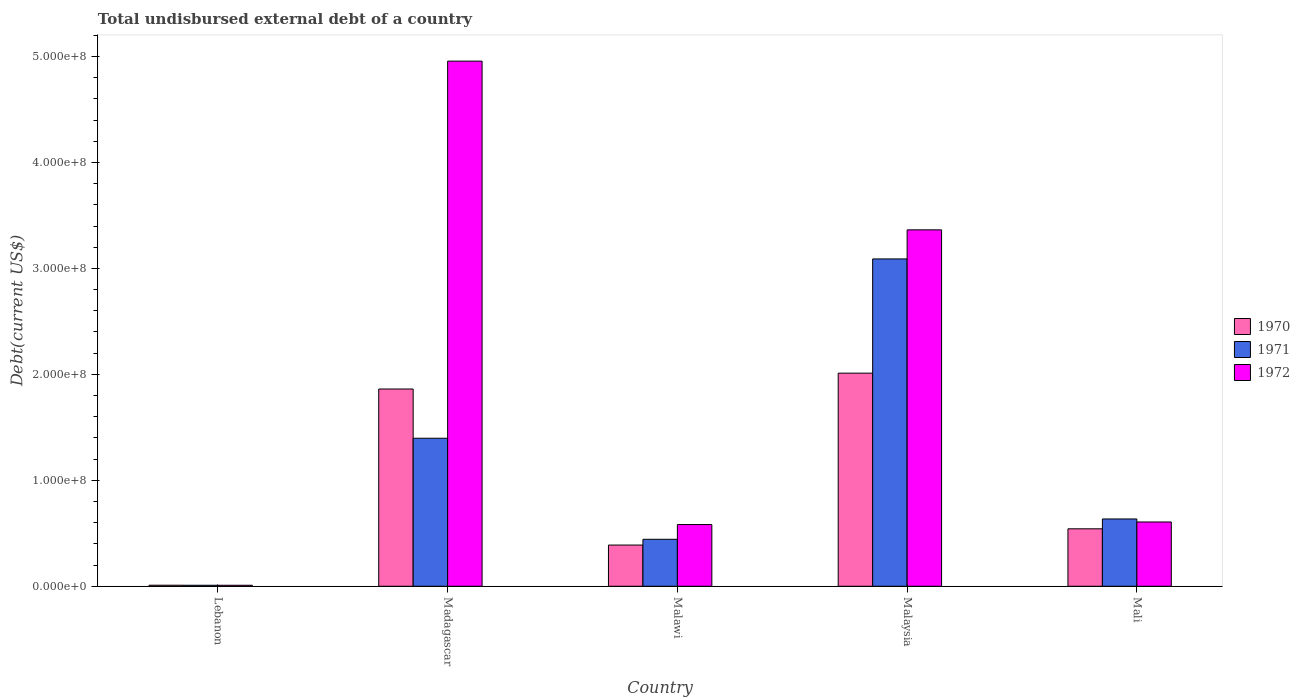Are the number of bars per tick equal to the number of legend labels?
Your answer should be compact. Yes. Are the number of bars on each tick of the X-axis equal?
Offer a terse response. Yes. What is the label of the 3rd group of bars from the left?
Give a very brief answer. Malawi. What is the total undisbursed external debt in 1971 in Lebanon?
Offer a terse response. 9.32e+05. Across all countries, what is the maximum total undisbursed external debt in 1971?
Your answer should be compact. 3.09e+08. Across all countries, what is the minimum total undisbursed external debt in 1971?
Your answer should be compact. 9.32e+05. In which country was the total undisbursed external debt in 1971 maximum?
Give a very brief answer. Malaysia. In which country was the total undisbursed external debt in 1970 minimum?
Keep it short and to the point. Lebanon. What is the total total undisbursed external debt in 1972 in the graph?
Provide a short and direct response. 9.52e+08. What is the difference between the total undisbursed external debt in 1971 in Lebanon and that in Mali?
Your response must be concise. -6.26e+07. What is the difference between the total undisbursed external debt in 1971 in Malawi and the total undisbursed external debt in 1970 in Malaysia?
Offer a terse response. -1.57e+08. What is the average total undisbursed external debt in 1970 per country?
Keep it short and to the point. 9.63e+07. What is the difference between the total undisbursed external debt of/in 1970 and total undisbursed external debt of/in 1971 in Malaysia?
Your answer should be very brief. -1.08e+08. In how many countries, is the total undisbursed external debt in 1970 greater than 480000000 US$?
Ensure brevity in your answer.  0. What is the ratio of the total undisbursed external debt in 1971 in Lebanon to that in Mali?
Your response must be concise. 0.01. Is the total undisbursed external debt in 1972 in Malaysia less than that in Mali?
Offer a terse response. No. Is the difference between the total undisbursed external debt in 1970 in Malawi and Mali greater than the difference between the total undisbursed external debt in 1971 in Malawi and Mali?
Your answer should be very brief. Yes. What is the difference between the highest and the second highest total undisbursed external debt in 1970?
Ensure brevity in your answer.  1.50e+07. What is the difference between the highest and the lowest total undisbursed external debt in 1970?
Your answer should be compact. 2.00e+08. Is the sum of the total undisbursed external debt in 1970 in Malawi and Malaysia greater than the maximum total undisbursed external debt in 1972 across all countries?
Your response must be concise. No. What does the 1st bar from the left in Malaysia represents?
Provide a short and direct response. 1970. What does the 2nd bar from the right in Malawi represents?
Keep it short and to the point. 1971. How many bars are there?
Provide a succinct answer. 15. How many countries are there in the graph?
Give a very brief answer. 5. What is the difference between two consecutive major ticks on the Y-axis?
Your answer should be very brief. 1.00e+08. Does the graph contain any zero values?
Provide a succinct answer. No. What is the title of the graph?
Your answer should be compact. Total undisbursed external debt of a country. What is the label or title of the Y-axis?
Offer a terse response. Debt(current US$). What is the Debt(current US$) in 1970 in Lebanon?
Your answer should be very brief. 9.80e+05. What is the Debt(current US$) of 1971 in Lebanon?
Provide a short and direct response. 9.32e+05. What is the Debt(current US$) in 1972 in Lebanon?
Your answer should be very brief. 9.32e+05. What is the Debt(current US$) of 1970 in Madagascar?
Provide a short and direct response. 1.86e+08. What is the Debt(current US$) in 1971 in Madagascar?
Provide a succinct answer. 1.40e+08. What is the Debt(current US$) in 1972 in Madagascar?
Give a very brief answer. 4.96e+08. What is the Debt(current US$) of 1970 in Malawi?
Ensure brevity in your answer.  3.89e+07. What is the Debt(current US$) of 1971 in Malawi?
Your response must be concise. 4.43e+07. What is the Debt(current US$) of 1972 in Malawi?
Give a very brief answer. 5.83e+07. What is the Debt(current US$) in 1970 in Malaysia?
Your answer should be compact. 2.01e+08. What is the Debt(current US$) of 1971 in Malaysia?
Your response must be concise. 3.09e+08. What is the Debt(current US$) in 1972 in Malaysia?
Make the answer very short. 3.36e+08. What is the Debt(current US$) in 1970 in Mali?
Ensure brevity in your answer.  5.42e+07. What is the Debt(current US$) of 1971 in Mali?
Give a very brief answer. 6.35e+07. What is the Debt(current US$) in 1972 in Mali?
Your response must be concise. 6.07e+07. Across all countries, what is the maximum Debt(current US$) of 1970?
Offer a very short reply. 2.01e+08. Across all countries, what is the maximum Debt(current US$) in 1971?
Offer a very short reply. 3.09e+08. Across all countries, what is the maximum Debt(current US$) in 1972?
Offer a very short reply. 4.96e+08. Across all countries, what is the minimum Debt(current US$) in 1970?
Your response must be concise. 9.80e+05. Across all countries, what is the minimum Debt(current US$) in 1971?
Keep it short and to the point. 9.32e+05. Across all countries, what is the minimum Debt(current US$) of 1972?
Give a very brief answer. 9.32e+05. What is the total Debt(current US$) in 1970 in the graph?
Give a very brief answer. 4.81e+08. What is the total Debt(current US$) of 1971 in the graph?
Keep it short and to the point. 5.57e+08. What is the total Debt(current US$) in 1972 in the graph?
Offer a very short reply. 9.52e+08. What is the difference between the Debt(current US$) in 1970 in Lebanon and that in Madagascar?
Your response must be concise. -1.85e+08. What is the difference between the Debt(current US$) in 1971 in Lebanon and that in Madagascar?
Provide a short and direct response. -1.39e+08. What is the difference between the Debt(current US$) of 1972 in Lebanon and that in Madagascar?
Ensure brevity in your answer.  -4.95e+08. What is the difference between the Debt(current US$) of 1970 in Lebanon and that in Malawi?
Make the answer very short. -3.79e+07. What is the difference between the Debt(current US$) of 1971 in Lebanon and that in Malawi?
Offer a very short reply. -4.34e+07. What is the difference between the Debt(current US$) in 1972 in Lebanon and that in Malawi?
Provide a short and direct response. -5.73e+07. What is the difference between the Debt(current US$) of 1970 in Lebanon and that in Malaysia?
Provide a succinct answer. -2.00e+08. What is the difference between the Debt(current US$) of 1971 in Lebanon and that in Malaysia?
Ensure brevity in your answer.  -3.08e+08. What is the difference between the Debt(current US$) of 1972 in Lebanon and that in Malaysia?
Offer a very short reply. -3.35e+08. What is the difference between the Debt(current US$) of 1970 in Lebanon and that in Mali?
Keep it short and to the point. -5.32e+07. What is the difference between the Debt(current US$) of 1971 in Lebanon and that in Mali?
Make the answer very short. -6.26e+07. What is the difference between the Debt(current US$) in 1972 in Lebanon and that in Mali?
Ensure brevity in your answer.  -5.97e+07. What is the difference between the Debt(current US$) of 1970 in Madagascar and that in Malawi?
Give a very brief answer. 1.47e+08. What is the difference between the Debt(current US$) in 1971 in Madagascar and that in Malawi?
Your answer should be compact. 9.54e+07. What is the difference between the Debt(current US$) of 1972 in Madagascar and that in Malawi?
Give a very brief answer. 4.37e+08. What is the difference between the Debt(current US$) in 1970 in Madagascar and that in Malaysia?
Ensure brevity in your answer.  -1.50e+07. What is the difference between the Debt(current US$) of 1971 in Madagascar and that in Malaysia?
Provide a succinct answer. -1.69e+08. What is the difference between the Debt(current US$) of 1972 in Madagascar and that in Malaysia?
Offer a very short reply. 1.59e+08. What is the difference between the Debt(current US$) in 1970 in Madagascar and that in Mali?
Your response must be concise. 1.32e+08. What is the difference between the Debt(current US$) in 1971 in Madagascar and that in Mali?
Your response must be concise. 7.62e+07. What is the difference between the Debt(current US$) in 1972 in Madagascar and that in Mali?
Your answer should be compact. 4.35e+08. What is the difference between the Debt(current US$) in 1970 in Malawi and that in Malaysia?
Your answer should be very brief. -1.62e+08. What is the difference between the Debt(current US$) of 1971 in Malawi and that in Malaysia?
Your answer should be very brief. -2.65e+08. What is the difference between the Debt(current US$) of 1972 in Malawi and that in Malaysia?
Ensure brevity in your answer.  -2.78e+08. What is the difference between the Debt(current US$) of 1970 in Malawi and that in Mali?
Provide a short and direct response. -1.53e+07. What is the difference between the Debt(current US$) in 1971 in Malawi and that in Mali?
Provide a short and direct response. -1.92e+07. What is the difference between the Debt(current US$) of 1972 in Malawi and that in Mali?
Keep it short and to the point. -2.41e+06. What is the difference between the Debt(current US$) in 1970 in Malaysia and that in Mali?
Give a very brief answer. 1.47e+08. What is the difference between the Debt(current US$) in 1971 in Malaysia and that in Mali?
Provide a succinct answer. 2.45e+08. What is the difference between the Debt(current US$) of 1972 in Malaysia and that in Mali?
Offer a very short reply. 2.76e+08. What is the difference between the Debt(current US$) in 1970 in Lebanon and the Debt(current US$) in 1971 in Madagascar?
Provide a short and direct response. -1.39e+08. What is the difference between the Debt(current US$) in 1970 in Lebanon and the Debt(current US$) in 1972 in Madagascar?
Make the answer very short. -4.95e+08. What is the difference between the Debt(current US$) of 1971 in Lebanon and the Debt(current US$) of 1972 in Madagascar?
Offer a very short reply. -4.95e+08. What is the difference between the Debt(current US$) of 1970 in Lebanon and the Debt(current US$) of 1971 in Malawi?
Provide a succinct answer. -4.34e+07. What is the difference between the Debt(current US$) of 1970 in Lebanon and the Debt(current US$) of 1972 in Malawi?
Ensure brevity in your answer.  -5.73e+07. What is the difference between the Debt(current US$) of 1971 in Lebanon and the Debt(current US$) of 1972 in Malawi?
Give a very brief answer. -5.73e+07. What is the difference between the Debt(current US$) of 1970 in Lebanon and the Debt(current US$) of 1971 in Malaysia?
Offer a terse response. -3.08e+08. What is the difference between the Debt(current US$) in 1970 in Lebanon and the Debt(current US$) in 1972 in Malaysia?
Offer a very short reply. -3.35e+08. What is the difference between the Debt(current US$) of 1971 in Lebanon and the Debt(current US$) of 1972 in Malaysia?
Your answer should be compact. -3.35e+08. What is the difference between the Debt(current US$) of 1970 in Lebanon and the Debt(current US$) of 1971 in Mali?
Your answer should be very brief. -6.25e+07. What is the difference between the Debt(current US$) of 1970 in Lebanon and the Debt(current US$) of 1972 in Mali?
Offer a very short reply. -5.97e+07. What is the difference between the Debt(current US$) of 1971 in Lebanon and the Debt(current US$) of 1972 in Mali?
Give a very brief answer. -5.97e+07. What is the difference between the Debt(current US$) in 1970 in Madagascar and the Debt(current US$) in 1971 in Malawi?
Keep it short and to the point. 1.42e+08. What is the difference between the Debt(current US$) of 1970 in Madagascar and the Debt(current US$) of 1972 in Malawi?
Provide a short and direct response. 1.28e+08. What is the difference between the Debt(current US$) of 1971 in Madagascar and the Debt(current US$) of 1972 in Malawi?
Offer a terse response. 8.14e+07. What is the difference between the Debt(current US$) in 1970 in Madagascar and the Debt(current US$) in 1971 in Malaysia?
Offer a very short reply. -1.23e+08. What is the difference between the Debt(current US$) in 1970 in Madagascar and the Debt(current US$) in 1972 in Malaysia?
Provide a short and direct response. -1.50e+08. What is the difference between the Debt(current US$) in 1971 in Madagascar and the Debt(current US$) in 1972 in Malaysia?
Offer a terse response. -1.97e+08. What is the difference between the Debt(current US$) in 1970 in Madagascar and the Debt(current US$) in 1971 in Mali?
Your answer should be compact. 1.23e+08. What is the difference between the Debt(current US$) of 1970 in Madagascar and the Debt(current US$) of 1972 in Mali?
Offer a very short reply. 1.26e+08. What is the difference between the Debt(current US$) of 1971 in Madagascar and the Debt(current US$) of 1972 in Mali?
Your response must be concise. 7.90e+07. What is the difference between the Debt(current US$) of 1970 in Malawi and the Debt(current US$) of 1971 in Malaysia?
Make the answer very short. -2.70e+08. What is the difference between the Debt(current US$) of 1970 in Malawi and the Debt(current US$) of 1972 in Malaysia?
Provide a succinct answer. -2.98e+08. What is the difference between the Debt(current US$) of 1971 in Malawi and the Debt(current US$) of 1972 in Malaysia?
Provide a short and direct response. -2.92e+08. What is the difference between the Debt(current US$) in 1970 in Malawi and the Debt(current US$) in 1971 in Mali?
Provide a short and direct response. -2.46e+07. What is the difference between the Debt(current US$) in 1970 in Malawi and the Debt(current US$) in 1972 in Mali?
Make the answer very short. -2.18e+07. What is the difference between the Debt(current US$) in 1971 in Malawi and the Debt(current US$) in 1972 in Mali?
Offer a terse response. -1.63e+07. What is the difference between the Debt(current US$) of 1970 in Malaysia and the Debt(current US$) of 1971 in Mali?
Your response must be concise. 1.38e+08. What is the difference between the Debt(current US$) of 1970 in Malaysia and the Debt(current US$) of 1972 in Mali?
Ensure brevity in your answer.  1.40e+08. What is the difference between the Debt(current US$) in 1971 in Malaysia and the Debt(current US$) in 1972 in Mali?
Your answer should be very brief. 2.48e+08. What is the average Debt(current US$) of 1970 per country?
Ensure brevity in your answer.  9.63e+07. What is the average Debt(current US$) of 1971 per country?
Offer a terse response. 1.11e+08. What is the average Debt(current US$) of 1972 per country?
Your answer should be very brief. 1.90e+08. What is the difference between the Debt(current US$) in 1970 and Debt(current US$) in 1971 in Lebanon?
Provide a short and direct response. 4.80e+04. What is the difference between the Debt(current US$) in 1970 and Debt(current US$) in 1972 in Lebanon?
Your answer should be very brief. 4.80e+04. What is the difference between the Debt(current US$) in 1970 and Debt(current US$) in 1971 in Madagascar?
Offer a very short reply. 4.65e+07. What is the difference between the Debt(current US$) in 1970 and Debt(current US$) in 1972 in Madagascar?
Ensure brevity in your answer.  -3.09e+08. What is the difference between the Debt(current US$) of 1971 and Debt(current US$) of 1972 in Madagascar?
Your response must be concise. -3.56e+08. What is the difference between the Debt(current US$) in 1970 and Debt(current US$) in 1971 in Malawi?
Your answer should be very brief. -5.45e+06. What is the difference between the Debt(current US$) of 1970 and Debt(current US$) of 1972 in Malawi?
Your answer should be very brief. -1.94e+07. What is the difference between the Debt(current US$) of 1971 and Debt(current US$) of 1972 in Malawi?
Provide a short and direct response. -1.39e+07. What is the difference between the Debt(current US$) in 1970 and Debt(current US$) in 1971 in Malaysia?
Provide a succinct answer. -1.08e+08. What is the difference between the Debt(current US$) of 1970 and Debt(current US$) of 1972 in Malaysia?
Provide a short and direct response. -1.35e+08. What is the difference between the Debt(current US$) of 1971 and Debt(current US$) of 1972 in Malaysia?
Your answer should be very brief. -2.74e+07. What is the difference between the Debt(current US$) of 1970 and Debt(current US$) of 1971 in Mali?
Your answer should be compact. -9.29e+06. What is the difference between the Debt(current US$) of 1970 and Debt(current US$) of 1972 in Mali?
Offer a terse response. -6.43e+06. What is the difference between the Debt(current US$) in 1971 and Debt(current US$) in 1972 in Mali?
Make the answer very short. 2.86e+06. What is the ratio of the Debt(current US$) of 1970 in Lebanon to that in Madagascar?
Offer a terse response. 0.01. What is the ratio of the Debt(current US$) of 1971 in Lebanon to that in Madagascar?
Make the answer very short. 0.01. What is the ratio of the Debt(current US$) in 1972 in Lebanon to that in Madagascar?
Make the answer very short. 0. What is the ratio of the Debt(current US$) in 1970 in Lebanon to that in Malawi?
Ensure brevity in your answer.  0.03. What is the ratio of the Debt(current US$) in 1971 in Lebanon to that in Malawi?
Offer a terse response. 0.02. What is the ratio of the Debt(current US$) of 1972 in Lebanon to that in Malawi?
Give a very brief answer. 0.02. What is the ratio of the Debt(current US$) in 1970 in Lebanon to that in Malaysia?
Your answer should be compact. 0. What is the ratio of the Debt(current US$) of 1971 in Lebanon to that in Malaysia?
Keep it short and to the point. 0. What is the ratio of the Debt(current US$) of 1972 in Lebanon to that in Malaysia?
Provide a short and direct response. 0. What is the ratio of the Debt(current US$) of 1970 in Lebanon to that in Mali?
Give a very brief answer. 0.02. What is the ratio of the Debt(current US$) in 1971 in Lebanon to that in Mali?
Keep it short and to the point. 0.01. What is the ratio of the Debt(current US$) of 1972 in Lebanon to that in Mali?
Your answer should be compact. 0.02. What is the ratio of the Debt(current US$) in 1970 in Madagascar to that in Malawi?
Make the answer very short. 4.79. What is the ratio of the Debt(current US$) of 1971 in Madagascar to that in Malawi?
Your answer should be very brief. 3.15. What is the ratio of the Debt(current US$) in 1972 in Madagascar to that in Malawi?
Offer a terse response. 8.51. What is the ratio of the Debt(current US$) in 1970 in Madagascar to that in Malaysia?
Your response must be concise. 0.93. What is the ratio of the Debt(current US$) of 1971 in Madagascar to that in Malaysia?
Provide a short and direct response. 0.45. What is the ratio of the Debt(current US$) of 1972 in Madagascar to that in Malaysia?
Your answer should be compact. 1.47. What is the ratio of the Debt(current US$) of 1970 in Madagascar to that in Mali?
Your answer should be very brief. 3.43. What is the ratio of the Debt(current US$) in 1971 in Madagascar to that in Mali?
Ensure brevity in your answer.  2.2. What is the ratio of the Debt(current US$) in 1972 in Madagascar to that in Mali?
Offer a terse response. 8.17. What is the ratio of the Debt(current US$) of 1970 in Malawi to that in Malaysia?
Your answer should be compact. 0.19. What is the ratio of the Debt(current US$) in 1971 in Malawi to that in Malaysia?
Make the answer very short. 0.14. What is the ratio of the Debt(current US$) in 1972 in Malawi to that in Malaysia?
Provide a succinct answer. 0.17. What is the ratio of the Debt(current US$) in 1970 in Malawi to that in Mali?
Ensure brevity in your answer.  0.72. What is the ratio of the Debt(current US$) in 1971 in Malawi to that in Mali?
Your answer should be compact. 0.7. What is the ratio of the Debt(current US$) in 1972 in Malawi to that in Mali?
Make the answer very short. 0.96. What is the ratio of the Debt(current US$) in 1970 in Malaysia to that in Mali?
Provide a succinct answer. 3.71. What is the ratio of the Debt(current US$) of 1971 in Malaysia to that in Mali?
Give a very brief answer. 4.86. What is the ratio of the Debt(current US$) in 1972 in Malaysia to that in Mali?
Provide a short and direct response. 5.55. What is the difference between the highest and the second highest Debt(current US$) of 1970?
Your response must be concise. 1.50e+07. What is the difference between the highest and the second highest Debt(current US$) of 1971?
Give a very brief answer. 1.69e+08. What is the difference between the highest and the second highest Debt(current US$) in 1972?
Your response must be concise. 1.59e+08. What is the difference between the highest and the lowest Debt(current US$) in 1970?
Give a very brief answer. 2.00e+08. What is the difference between the highest and the lowest Debt(current US$) in 1971?
Give a very brief answer. 3.08e+08. What is the difference between the highest and the lowest Debt(current US$) of 1972?
Give a very brief answer. 4.95e+08. 